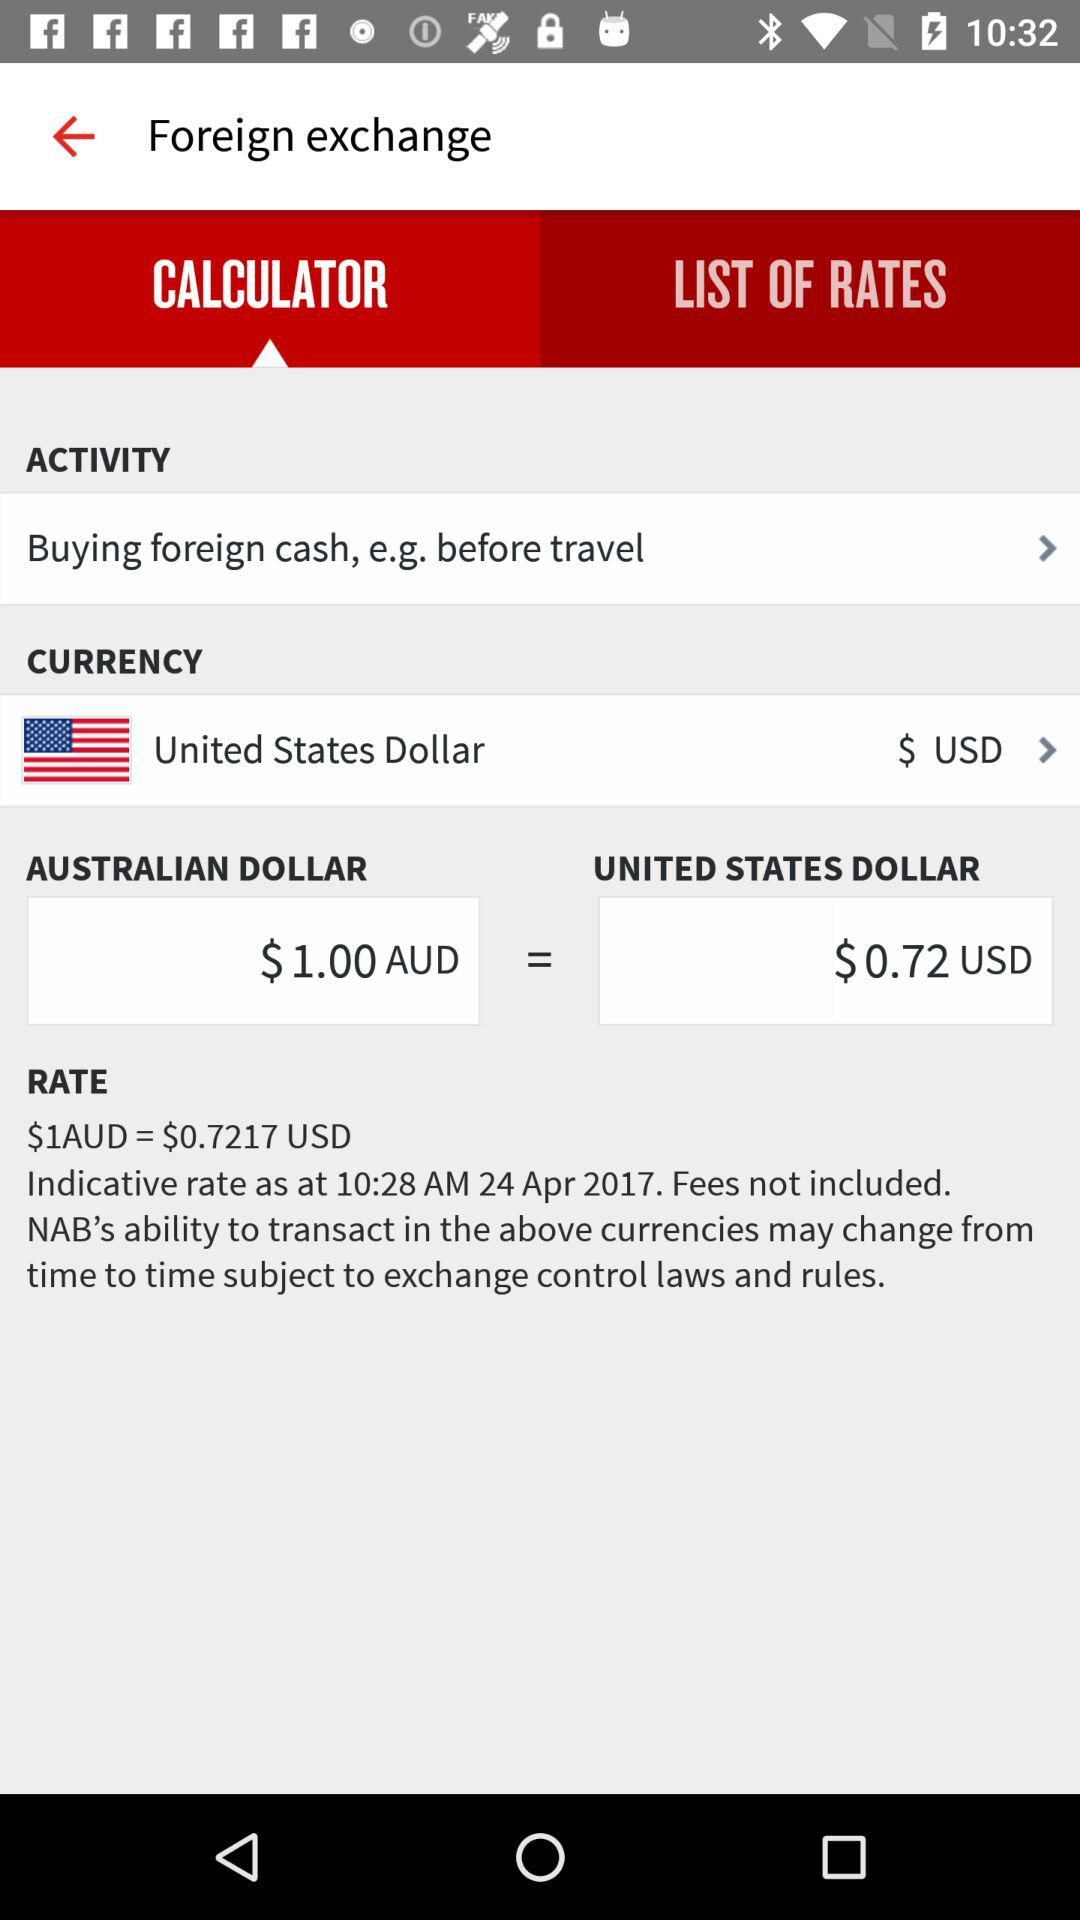What is the activity? The activity is "Buying foreign cash, e.g. before travel". 